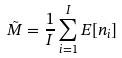<formula> <loc_0><loc_0><loc_500><loc_500>\tilde { M } = \frac { 1 } { I } \sum _ { i = 1 } ^ { I } E [ n _ { i } ]</formula> 